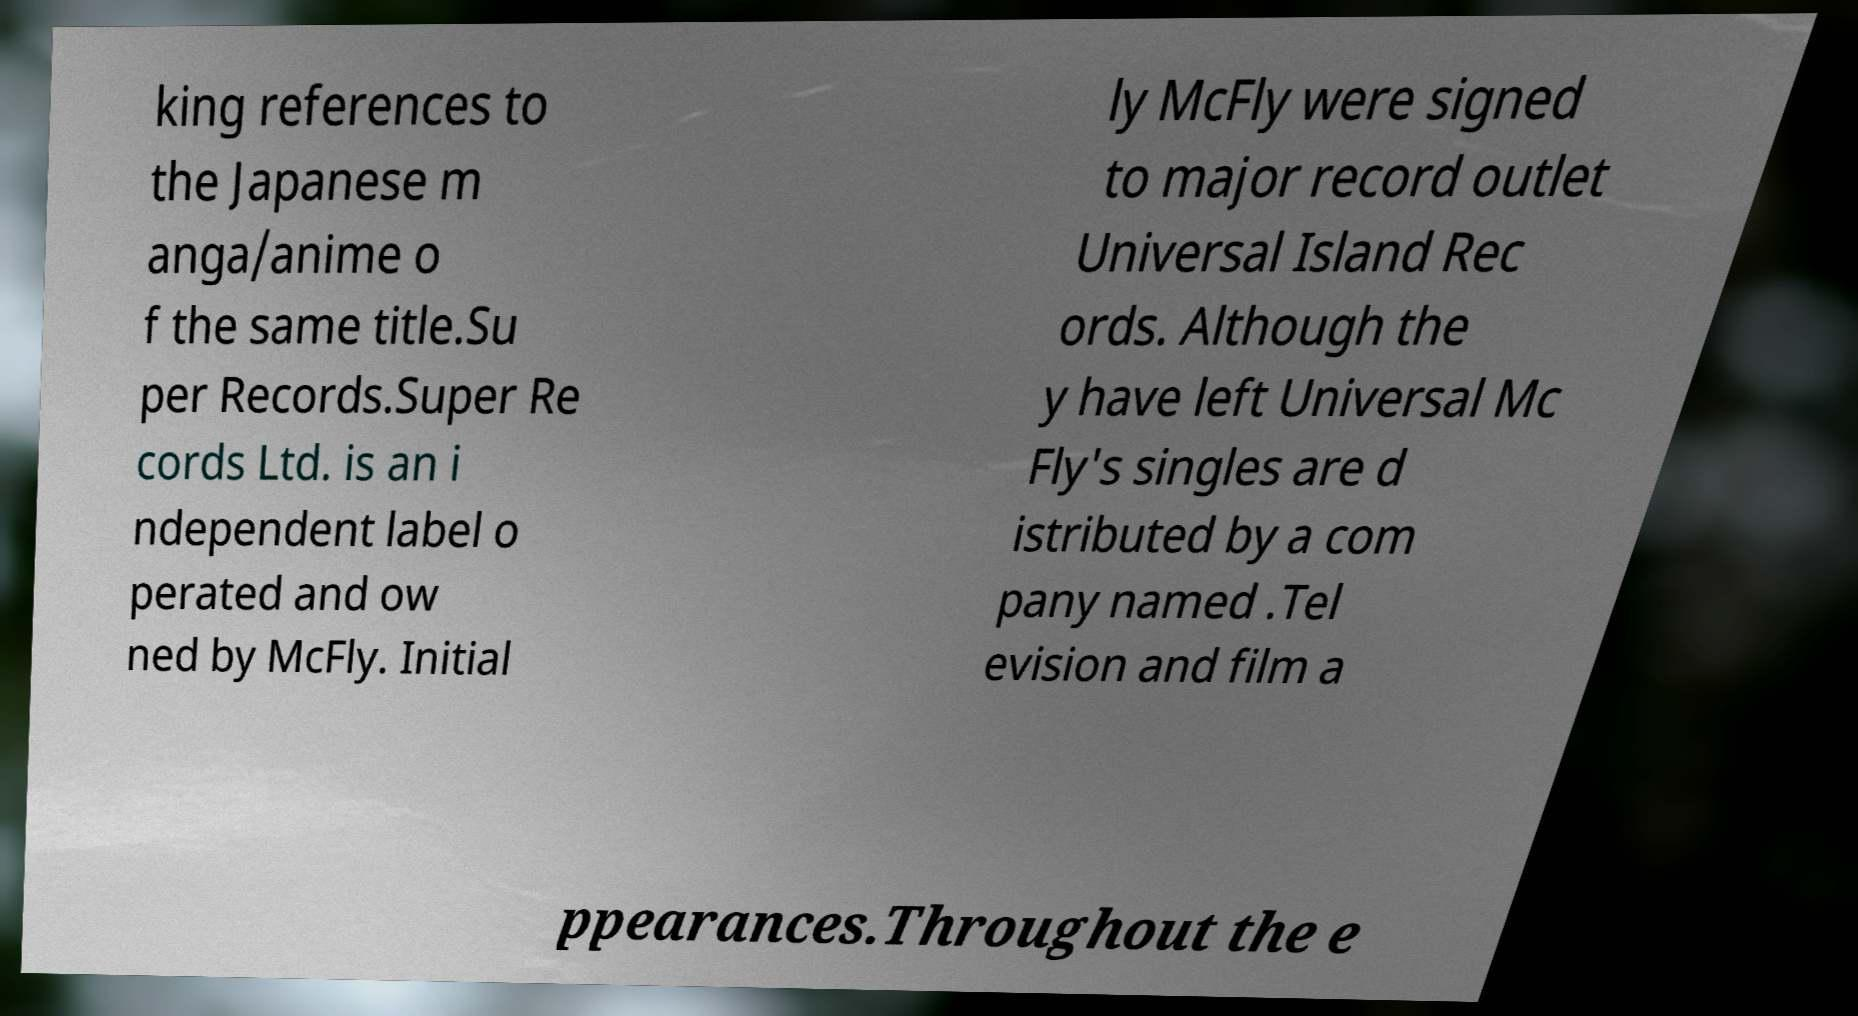Could you extract and type out the text from this image? king references to the Japanese m anga/anime o f the same title.Su per Records.Super Re cords Ltd. is an i ndependent label o perated and ow ned by McFly. Initial ly McFly were signed to major record outlet Universal Island Rec ords. Although the y have left Universal Mc Fly's singles are d istributed by a com pany named .Tel evision and film a ppearances.Throughout the e 